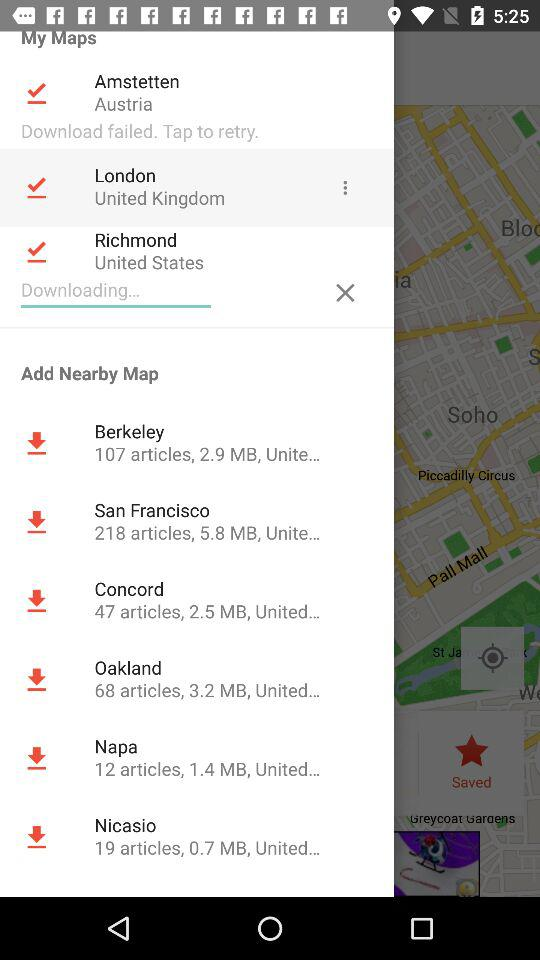How many articles are there in the Berkeley map? There are 107 articles. 